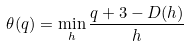<formula> <loc_0><loc_0><loc_500><loc_500>\theta ( q ) = \min _ { h } \frac { q + 3 - D ( h ) } { h }</formula> 